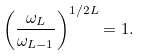<formula> <loc_0><loc_0><loc_500><loc_500>\left ( \frac { \omega _ { L } } { \omega _ { L - 1 } } \right ) ^ { 1 / 2 L } = 1 .</formula> 